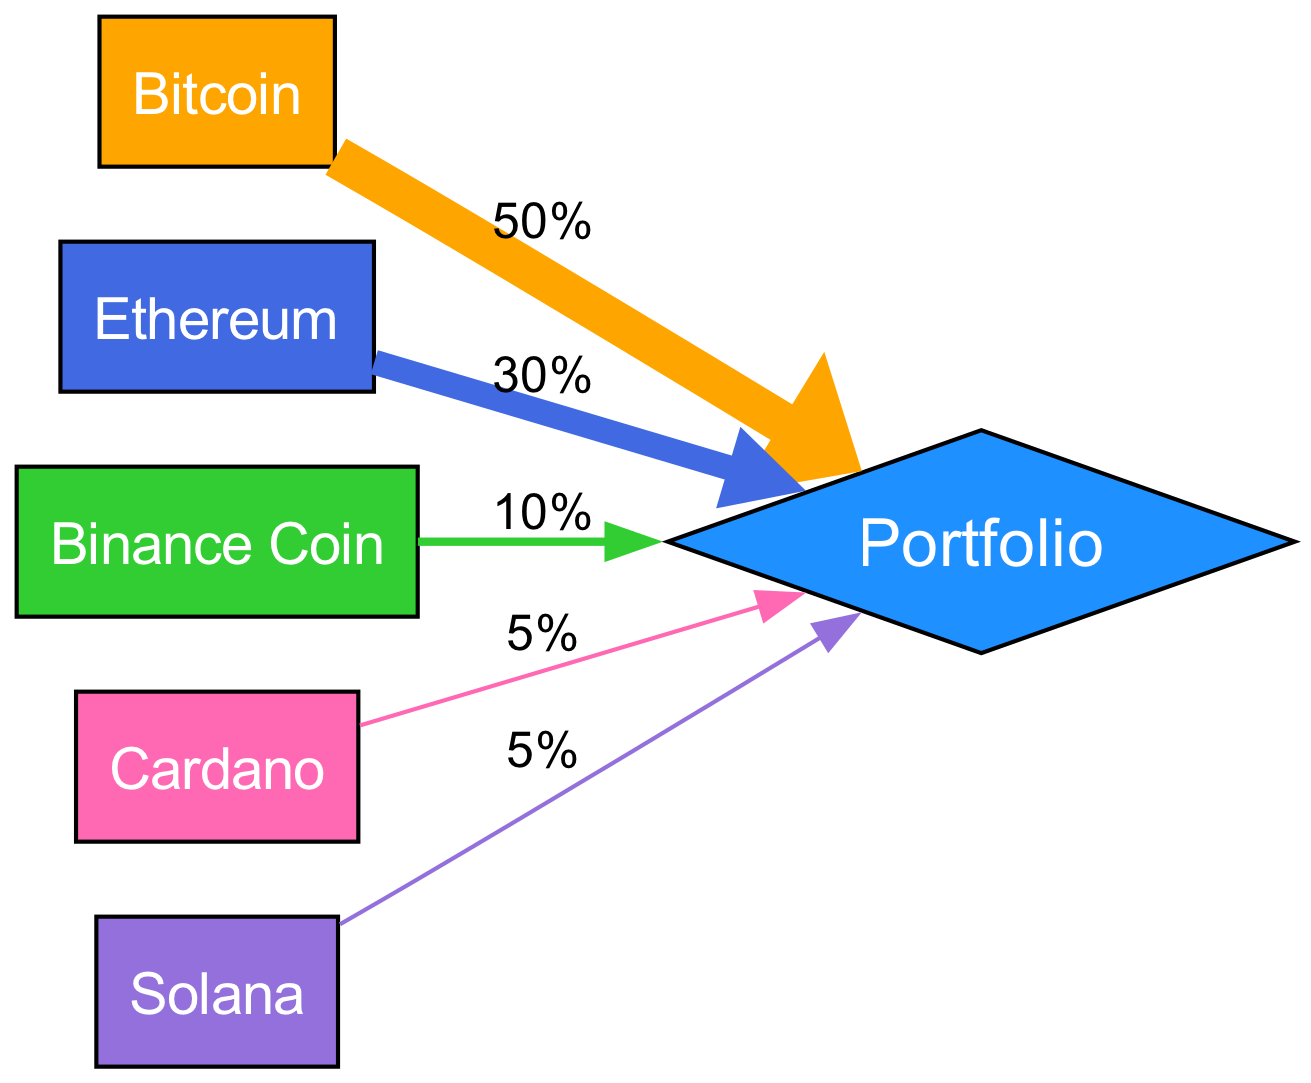What is the percentage allocation for Bitcoin? The diagram shows a direct link from Bitcoin to the Portfolio node labeled with the value '50%'. This indicates that 50% of the portfolio is allocated to Bitcoin.
Answer: 50% Which digital asset has the lowest allocation in the portfolio? By examining the links, Cardano and Solana both have direct links to the Portfolio node with a value of '5%'. Thus, they both have the lowest allocation.
Answer: Cardano and Solana How many total nodes are there in the diagram? The diagram consists of 5 distinct digital asset nodes (Bitcoin, Ethereum, Binance Coin, Cardano, and Solana) plus one 'Portfolio' node, making a total of 6 nodes.
Answer: 6 Which digital asset contributes 10% to the portfolio? The link from Binance Coin to the Portfolio node shows a value of '10%', indicating that Binance Coin contributes this percentage to the overall portfolio.
Answer: Binance Coin What percentage of the portfolio is allocated to Ethereum and Binance Coin combined? To find this, we add Ethereum's allocation of 30% and Binance Coin's allocation of 10%. Therefore, 30% + 10% equals 40%.
Answer: 40% What is the total percentage allocation for the portfolio? The diagram aggregates the allocations from all the assets to the Portfolio node, confirming that the total allocation is 100% (50% + 30% + 10% + 5% + 5%).
Answer: 100% Which node has the highest allocation in the diagram? The link from Bitcoin to the Portfolio node is labeled '50%', which is the highest value compared to the other nodes. Thus, Bitcoin has the highest allocation.
Answer: Bitcoin What color represents Cardano in the diagram? The color assigned to Cardano is identified in the color palette utilized, which corresponds with the node for Cardano. Upon inspection, Cardano is colored with '#FF69B4'.
Answer: Pink Which two nodes have the same allocation value? The diagram indicates that both Cardano and Solana have an allocation value of '5%', making them equal in percentage contribution to the Portfolio.
Answer: Cardano and Solana 